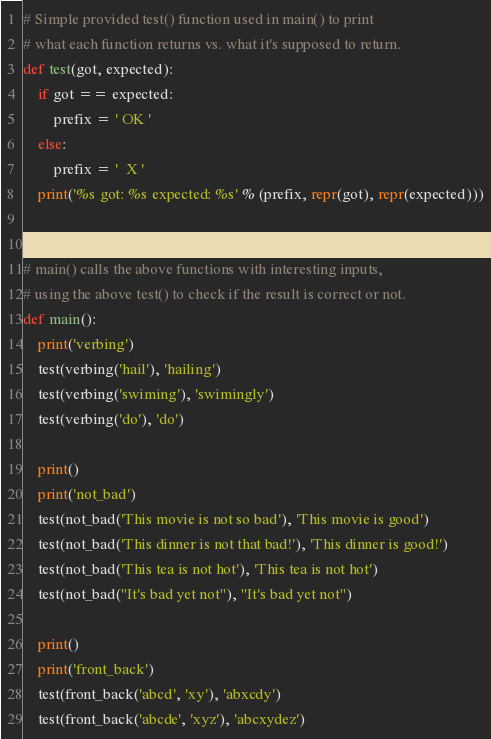<code> <loc_0><loc_0><loc_500><loc_500><_Python_>

# Simple provided test() function used in main() to print
# what each function returns vs. what it's supposed to return.
def test(got, expected):
    if got == expected:
        prefix = ' OK '
    else:
        prefix = '  X '
    print('%s got: %s expected: %s' % (prefix, repr(got), repr(expected)))


# main() calls the above functions with interesting inputs,
# using the above test() to check if the result is correct or not.
def main():
    print('verbing')
    test(verbing('hail'), 'hailing')
    test(verbing('swiming'), 'swimingly')
    test(verbing('do'), 'do')

    print()
    print('not_bad')
    test(not_bad('This movie is not so bad'), 'This movie is good')
    test(not_bad('This dinner is not that bad!'), 'This dinner is good!')
    test(not_bad('This tea is not hot'), 'This tea is not hot')
    test(not_bad("It's bad yet not"), "It's bad yet not")

    print()
    print('front_back')
    test(front_back('abcd', 'xy'), 'abxcdy')
    test(front_back('abcde', 'xyz'), 'abcxydez')</code> 